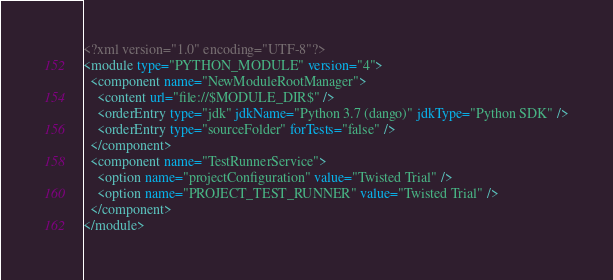Convert code to text. <code><loc_0><loc_0><loc_500><loc_500><_XML_><?xml version="1.0" encoding="UTF-8"?>
<module type="PYTHON_MODULE" version="4">
  <component name="NewModuleRootManager">
    <content url="file://$MODULE_DIR$" />
    <orderEntry type="jdk" jdkName="Python 3.7 (dango)" jdkType="Python SDK" />
    <orderEntry type="sourceFolder" forTests="false" />
  </component>
  <component name="TestRunnerService">
    <option name="projectConfiguration" value="Twisted Trial" />
    <option name="PROJECT_TEST_RUNNER" value="Twisted Trial" />
  </component>
</module></code> 